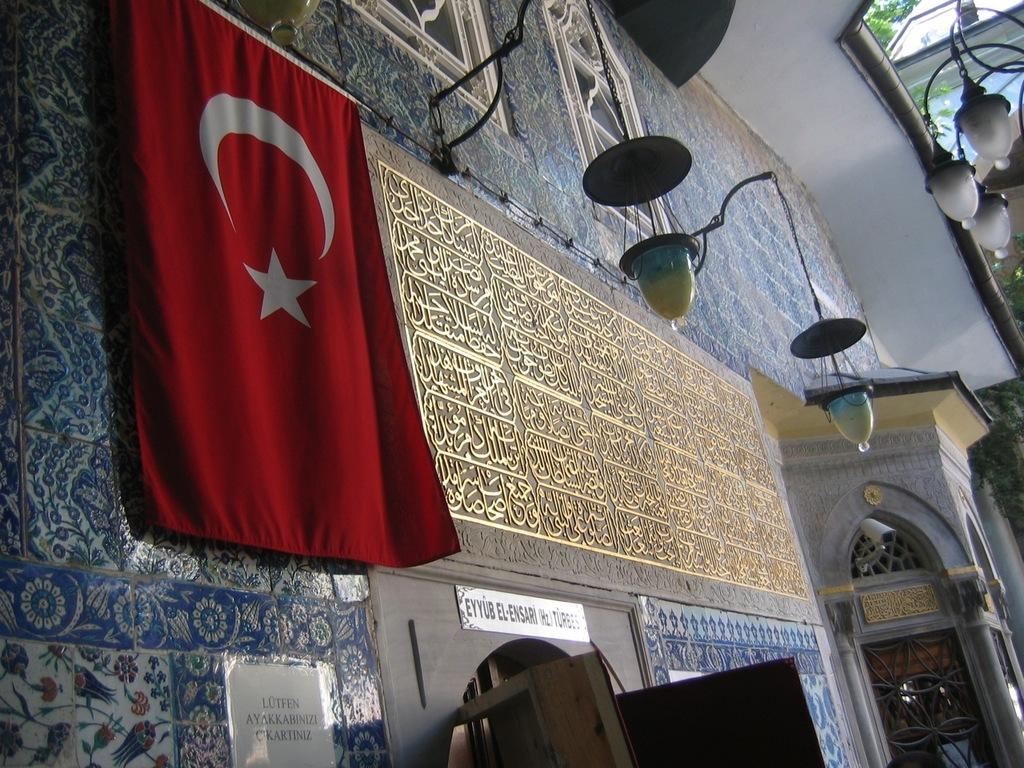What is the main object in the center of the image? There is an Arabic board in the center of the image. Where is the flag located in the image? The flag is on the left side of the image. What can be seen on the right side of the image? There are lamps on the right side of the image. How many trees are present in the image? There are no trees visible in the image. What type of arithmetic problem is being solved on the Arabic board? The image does not provide enough information to determine if an arithmetic problem is being solved on the Arabic board. 